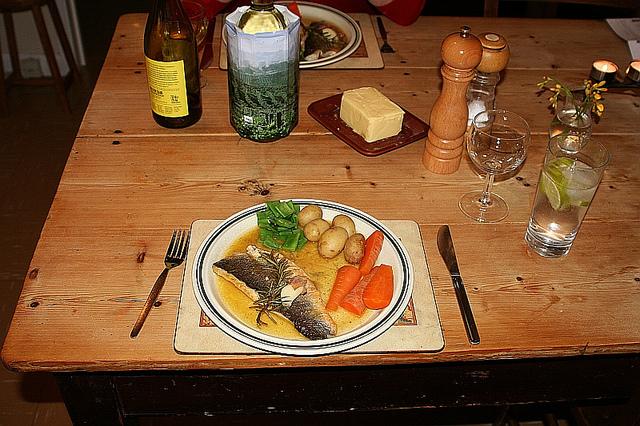What kind of wine is there?
Quick response, please. White. What kind of meat is on the plate?
Quick response, please. Fish. Is the meal a fancy one?
Short answer required. No. 